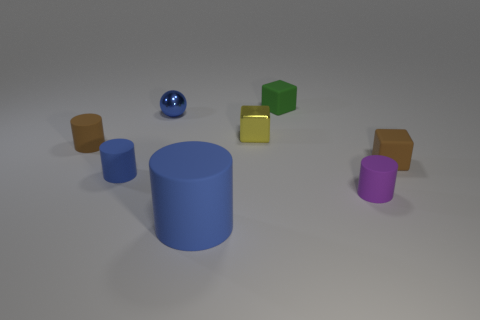There is a small shiny object that is the same shape as the small green matte thing; what is its color?
Offer a very short reply. Yellow. Is the brown thing right of the small green rubber thing made of the same material as the blue object that is in front of the purple matte thing?
Your answer should be very brief. Yes. There is a tiny shiny sphere; does it have the same color as the rubber block that is behind the brown cube?
Your answer should be very brief. No. What is the shape of the small matte thing that is on the right side of the green thing and on the left side of the small brown cube?
Ensure brevity in your answer.  Cylinder. How many tiny blue metallic balls are there?
Provide a short and direct response. 1. The small metal thing that is the same color as the large matte cylinder is what shape?
Make the answer very short. Sphere. There is a yellow metal object that is the same shape as the tiny green object; what is its size?
Make the answer very short. Small. There is a tiny brown matte object right of the large blue thing; is its shape the same as the small green thing?
Ensure brevity in your answer.  Yes. What color is the rubber cylinder in front of the purple matte cylinder?
Give a very brief answer. Blue. How many other things are the same size as the yellow thing?
Provide a succinct answer. 6. 